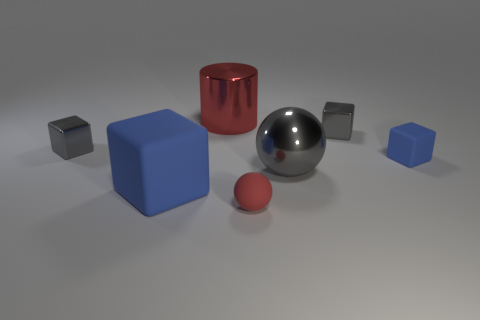There is a small shiny object that is on the right side of the large object in front of the big object to the right of the shiny cylinder; what is its shape? cube 